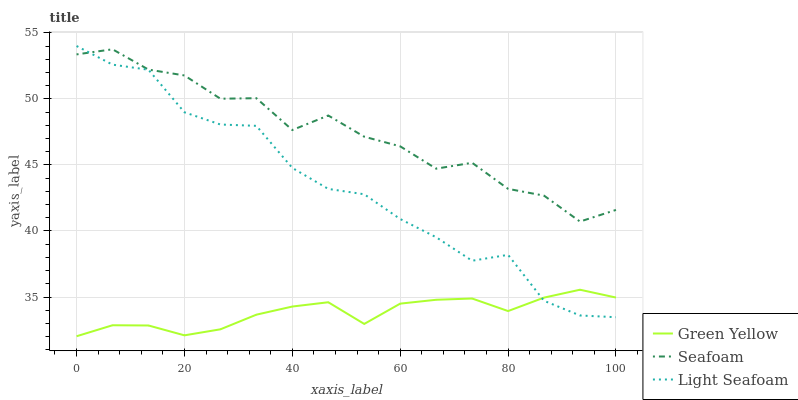Does Green Yellow have the minimum area under the curve?
Answer yes or no. Yes. Does Seafoam have the maximum area under the curve?
Answer yes or no. Yes. Does Light Seafoam have the minimum area under the curve?
Answer yes or no. No. Does Light Seafoam have the maximum area under the curve?
Answer yes or no. No. Is Green Yellow the smoothest?
Answer yes or no. Yes. Is Seafoam the roughest?
Answer yes or no. Yes. Is Light Seafoam the smoothest?
Answer yes or no. No. Is Light Seafoam the roughest?
Answer yes or no. No. Does Green Yellow have the lowest value?
Answer yes or no. Yes. Does Light Seafoam have the lowest value?
Answer yes or no. No. Does Light Seafoam have the highest value?
Answer yes or no. Yes. Does Seafoam have the highest value?
Answer yes or no. No. Is Green Yellow less than Seafoam?
Answer yes or no. Yes. Is Seafoam greater than Green Yellow?
Answer yes or no. Yes. Does Seafoam intersect Light Seafoam?
Answer yes or no. Yes. Is Seafoam less than Light Seafoam?
Answer yes or no. No. Is Seafoam greater than Light Seafoam?
Answer yes or no. No. Does Green Yellow intersect Seafoam?
Answer yes or no. No. 